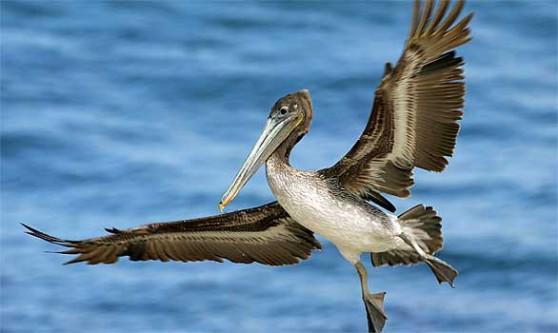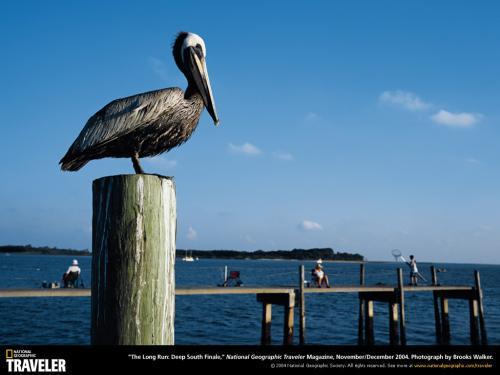The first image is the image on the left, the second image is the image on the right. Evaluate the accuracy of this statement regarding the images: "In one of the images, there is a pelican in flight". Is it true? Answer yes or no. Yes. 